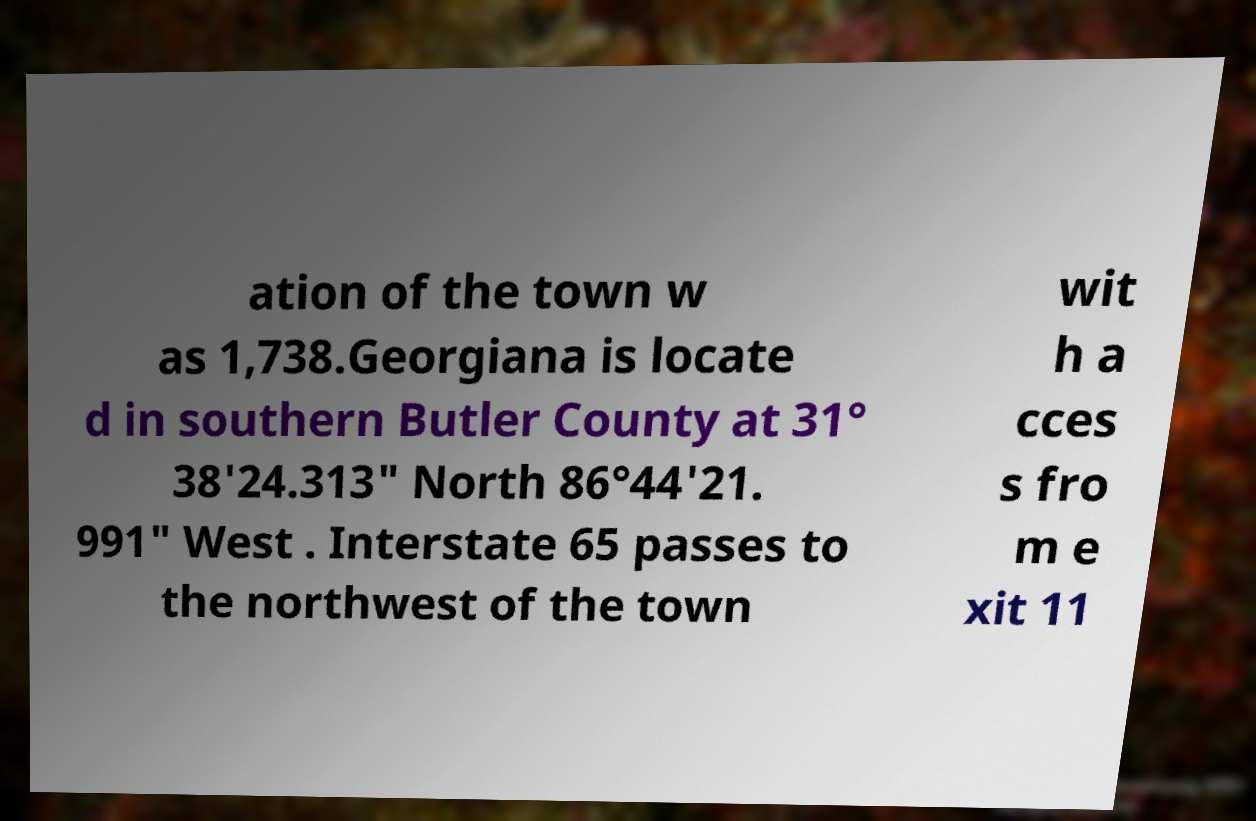Can you read and provide the text displayed in the image?This photo seems to have some interesting text. Can you extract and type it out for me? ation of the town w as 1,738.Georgiana is locate d in southern Butler County at 31° 38'24.313" North 86°44'21. 991" West . Interstate 65 passes to the northwest of the town wit h a cces s fro m e xit 11 